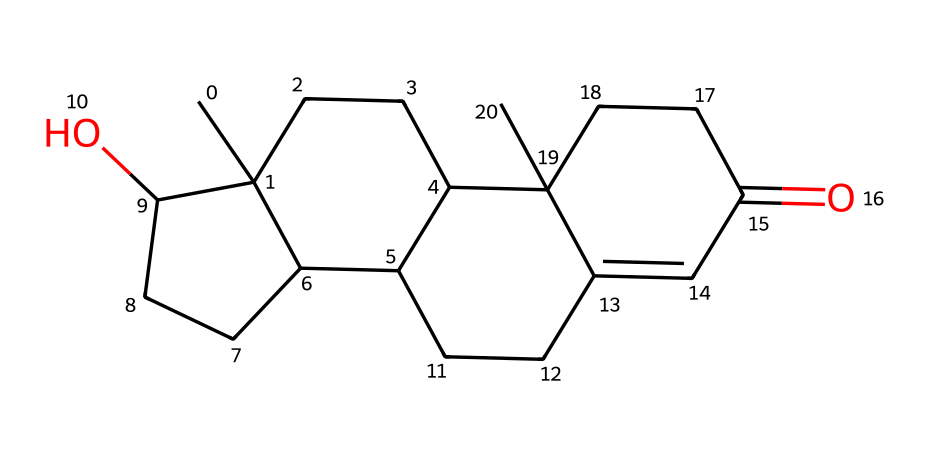What is the primary functional group present in testosterone? The SMILES representation indicates the presence of a ketone group, characterized by the carbonyl (C=O) functional group found within the cyclic structure. This is evidenced by the section "C(=O)" in the SMILES.
Answer: ketone How many carbon atoms are in testosterone? By examining the SMILES representation closely, we can identify each 'C' symbol, which stands for carbon atoms. There are a total of 19 carbon atoms present in the structure.
Answer: 19 What type of hormone is testosterone primarily classified as? Testosterone is classified as an androgen hormone. This is based on its biological role in male characteristics and its structural features typical of steroid hormones.
Answer: androgen What is the presence of an alcohol functional group in testosterone signified by? The presence of an alcohol functional group can be inferred from the 'O' in the structure, which indicates a hydroxyl (-OH) group attached to one of the carbon atoms in the steroid framework.
Answer: hydroxyl group What structural feature of testosterone is associated with its role in muscle growth? The steroid structure of testosterone allows for binding to androgen receptors, promoting muscle anabolism. This is observed from its overall fused ring system, characteristic of anabolic steroids.
Answer: steroid structure 